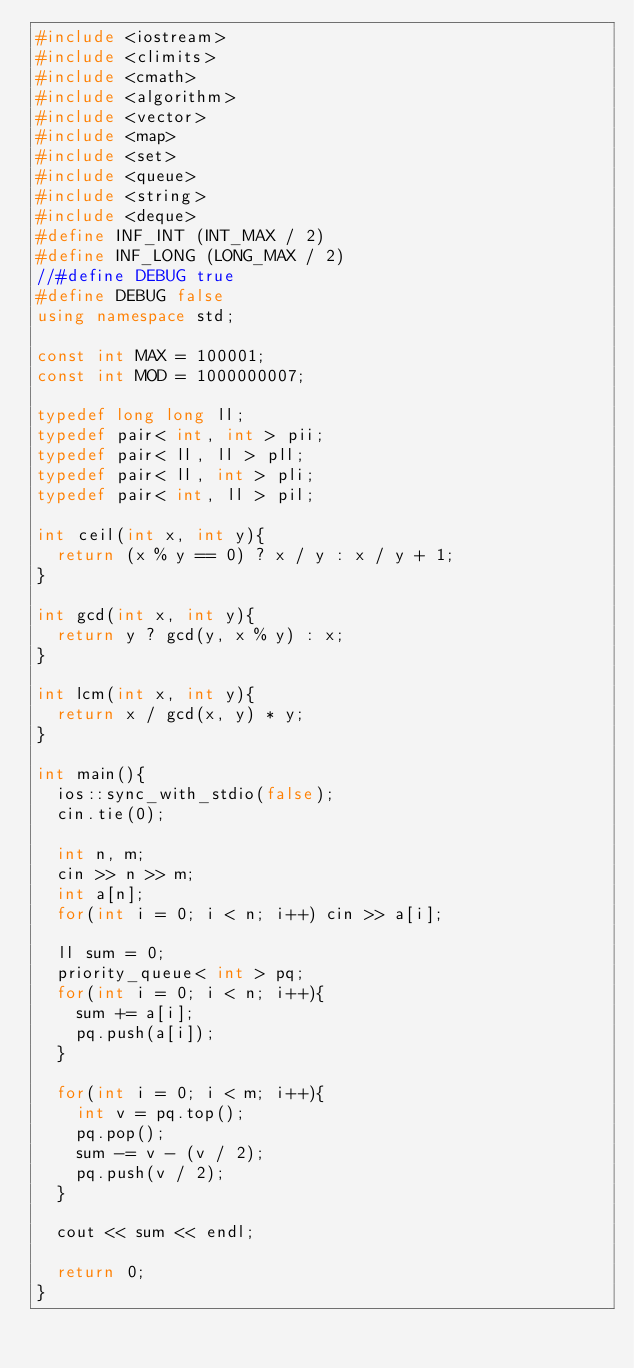Convert code to text. <code><loc_0><loc_0><loc_500><loc_500><_C++_>#include <iostream>
#include <climits>
#include <cmath>
#include <algorithm>
#include <vector>
#include <map>
#include <set>
#include <queue>
#include <string>
#include <deque>
#define INF_INT (INT_MAX / 2)
#define INF_LONG (LONG_MAX / 2)
//#define DEBUG true
#define DEBUG false
using namespace std;

const int MAX = 100001;
const int MOD = 1000000007;

typedef long long ll;
typedef pair< int, int > pii;
typedef pair< ll, ll > pll;
typedef pair< ll, int > pli;
typedef pair< int, ll > pil;

int ceil(int x, int y){
  return (x % y == 0) ? x / y : x / y + 1;
}

int gcd(int x, int y){
  return y ? gcd(y, x % y) : x;
}

int lcm(int x, int y){
  return x / gcd(x, y) * y;
}

int main(){
  ios::sync_with_stdio(false);
  cin.tie(0);

  int n, m;
  cin >> n >> m;
  int a[n];
  for(int i = 0; i < n; i++) cin >> a[i];

  ll sum = 0;
  priority_queue< int > pq;
  for(int i = 0; i < n; i++){
    sum += a[i];
    pq.push(a[i]);
  }

  for(int i = 0; i < m; i++){
    int v = pq.top();
    pq.pop();
    sum -= v - (v / 2);
    pq.push(v / 2);
  }

  cout << sum << endl;

  return 0;
}
</code> 